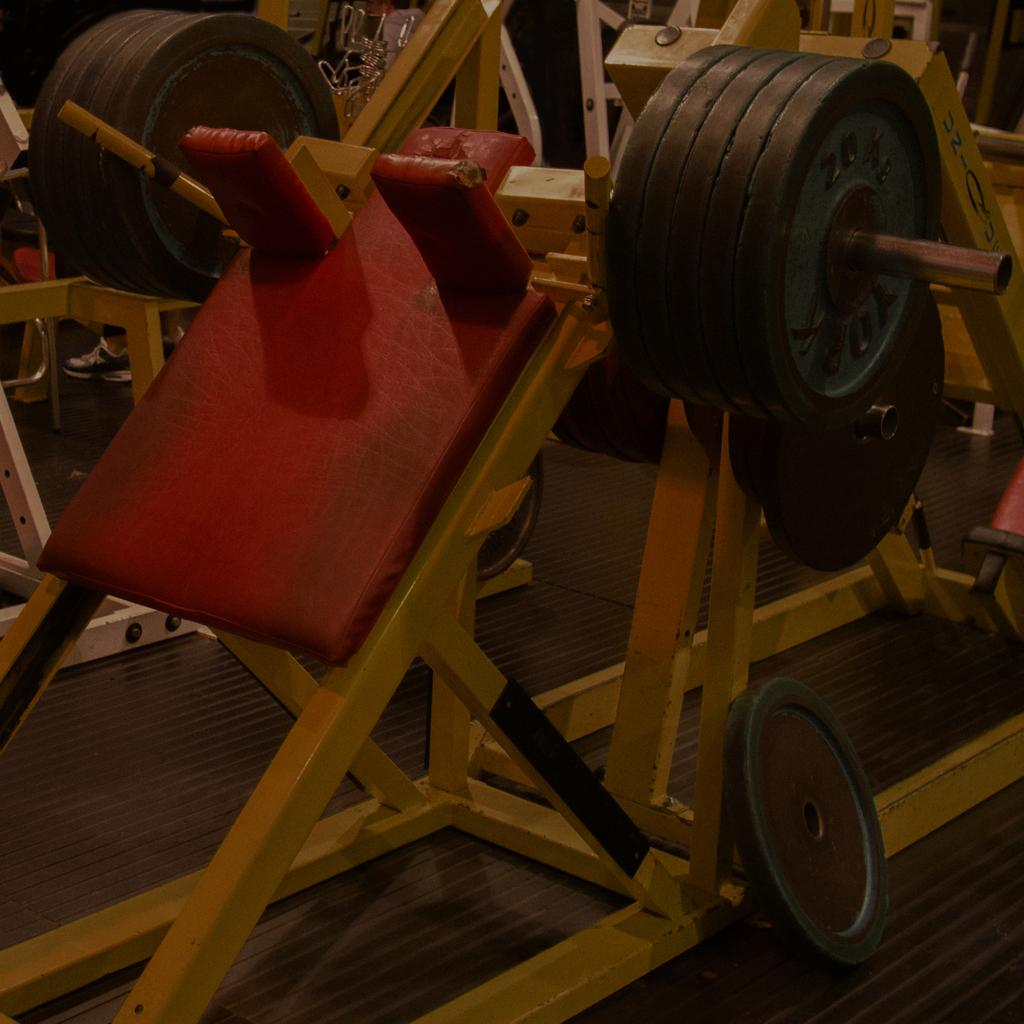What type of objects are on the floor in the image? There are gym equipments on the floor. Can you describe the gym equipments in the image? The gym equipments on the floor may include weights, exercise machines, or other fitness-related items. What color are the eyes of the person using the gym equipment in the image? There is no person present in the image, so we cannot determine the color of their eyes. 